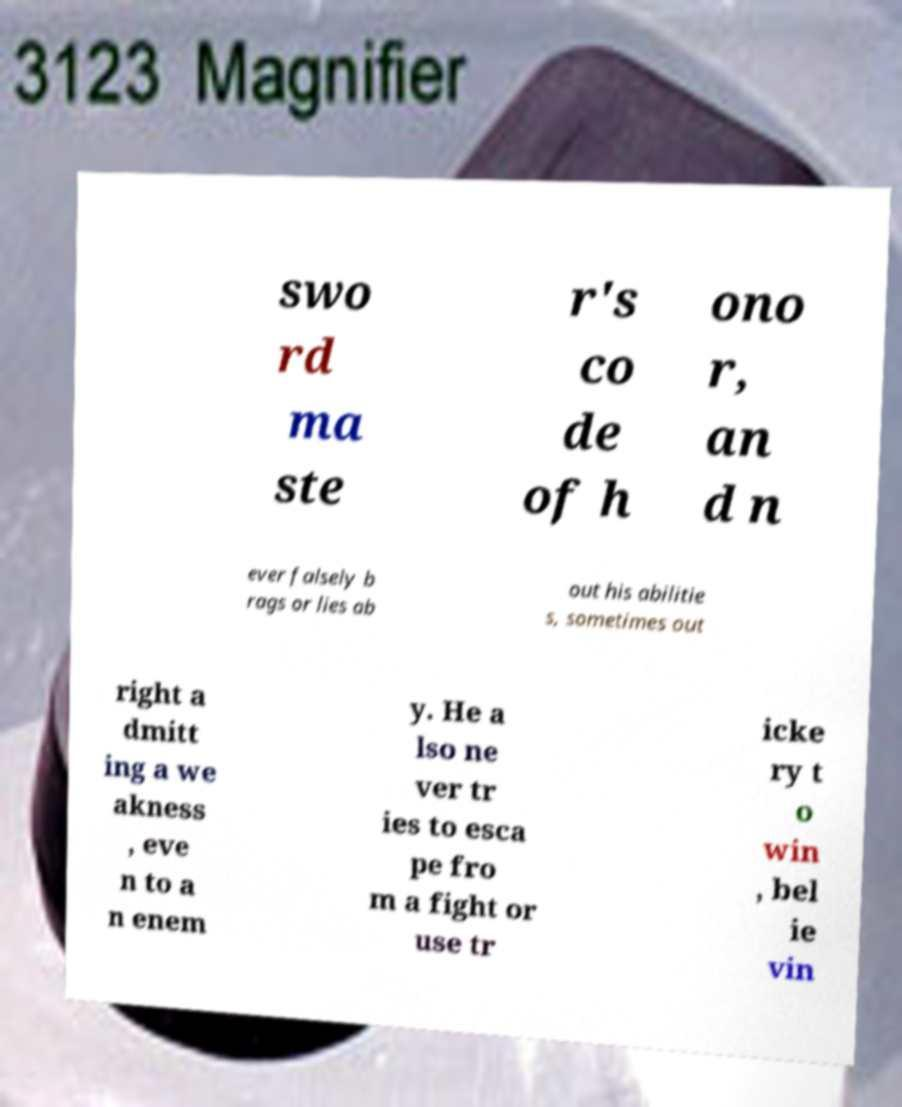Please read and relay the text visible in this image. What does it say? swo rd ma ste r's co de of h ono r, an d n ever falsely b rags or lies ab out his abilitie s, sometimes out right a dmitt ing a we akness , eve n to a n enem y. He a lso ne ver tr ies to esca pe fro m a fight or use tr icke ry t o win , bel ie vin 